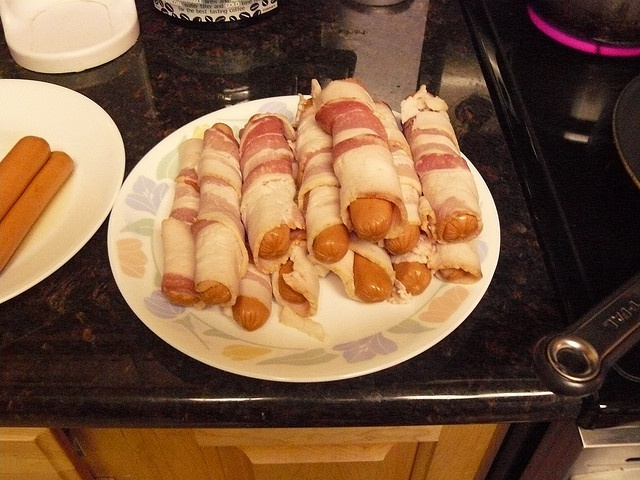Describe the objects in this image and their specific colors. I can see oven in tan, black, and maroon tones, hot dog in tan, brown, and salmon tones, hot dog in tan, brown, and red tones, hot dog in tan, brown, and salmon tones, and hot dog in tan and brown tones in this image. 